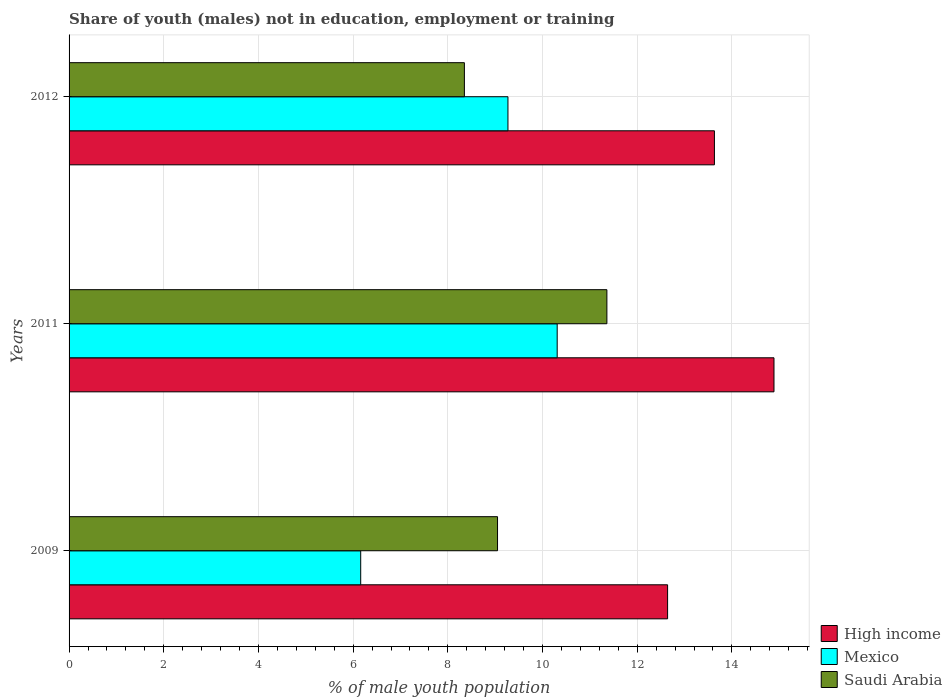How many different coloured bars are there?
Keep it short and to the point. 3. Are the number of bars on each tick of the Y-axis equal?
Provide a succinct answer. Yes. What is the percentage of unemployed males population in in High income in 2012?
Give a very brief answer. 13.63. Across all years, what is the maximum percentage of unemployed males population in in High income?
Offer a terse response. 14.89. Across all years, what is the minimum percentage of unemployed males population in in Mexico?
Your answer should be very brief. 6.16. In which year was the percentage of unemployed males population in in Mexico minimum?
Offer a terse response. 2009. What is the total percentage of unemployed males population in in High income in the graph?
Your answer should be compact. 41.16. What is the difference between the percentage of unemployed males population in in Mexico in 2009 and that in 2012?
Your response must be concise. -3.11. What is the difference between the percentage of unemployed males population in in Saudi Arabia in 2011 and the percentage of unemployed males population in in High income in 2012?
Ensure brevity in your answer.  -2.27. What is the average percentage of unemployed males population in in Saudi Arabia per year?
Give a very brief answer. 9.59. In the year 2012, what is the difference between the percentage of unemployed males population in in Saudi Arabia and percentage of unemployed males population in in Mexico?
Your answer should be very brief. -0.92. In how many years, is the percentage of unemployed males population in in Saudi Arabia greater than 14.4 %?
Keep it short and to the point. 0. What is the ratio of the percentage of unemployed males population in in Mexico in 2009 to that in 2011?
Your answer should be compact. 0.6. Is the difference between the percentage of unemployed males population in in Saudi Arabia in 2009 and 2012 greater than the difference between the percentage of unemployed males population in in Mexico in 2009 and 2012?
Offer a very short reply. Yes. What is the difference between the highest and the second highest percentage of unemployed males population in in Mexico?
Offer a very short reply. 1.04. What is the difference between the highest and the lowest percentage of unemployed males population in in Saudi Arabia?
Make the answer very short. 3.01. Is the sum of the percentage of unemployed males population in in Mexico in 2009 and 2011 greater than the maximum percentage of unemployed males population in in Saudi Arabia across all years?
Make the answer very short. Yes. Is it the case that in every year, the sum of the percentage of unemployed males population in in Saudi Arabia and percentage of unemployed males population in in Mexico is greater than the percentage of unemployed males population in in High income?
Give a very brief answer. Yes. Are the values on the major ticks of X-axis written in scientific E-notation?
Make the answer very short. No. Does the graph contain grids?
Provide a short and direct response. Yes. How many legend labels are there?
Offer a terse response. 3. What is the title of the graph?
Your response must be concise. Share of youth (males) not in education, employment or training. What is the label or title of the X-axis?
Your answer should be very brief. % of male youth population. What is the % of male youth population of High income in 2009?
Your answer should be compact. 12.64. What is the % of male youth population in Mexico in 2009?
Offer a terse response. 6.16. What is the % of male youth population in Saudi Arabia in 2009?
Provide a succinct answer. 9.05. What is the % of male youth population of High income in 2011?
Your answer should be very brief. 14.89. What is the % of male youth population in Mexico in 2011?
Offer a terse response. 10.31. What is the % of male youth population of Saudi Arabia in 2011?
Give a very brief answer. 11.36. What is the % of male youth population of High income in 2012?
Keep it short and to the point. 13.63. What is the % of male youth population of Mexico in 2012?
Your answer should be compact. 9.27. What is the % of male youth population in Saudi Arabia in 2012?
Provide a short and direct response. 8.35. Across all years, what is the maximum % of male youth population of High income?
Give a very brief answer. 14.89. Across all years, what is the maximum % of male youth population of Mexico?
Ensure brevity in your answer.  10.31. Across all years, what is the maximum % of male youth population of Saudi Arabia?
Your answer should be very brief. 11.36. Across all years, what is the minimum % of male youth population of High income?
Keep it short and to the point. 12.64. Across all years, what is the minimum % of male youth population in Mexico?
Give a very brief answer. 6.16. Across all years, what is the minimum % of male youth population of Saudi Arabia?
Offer a terse response. 8.35. What is the total % of male youth population of High income in the graph?
Your answer should be compact. 41.16. What is the total % of male youth population in Mexico in the graph?
Your response must be concise. 25.74. What is the total % of male youth population of Saudi Arabia in the graph?
Your answer should be compact. 28.76. What is the difference between the % of male youth population in High income in 2009 and that in 2011?
Ensure brevity in your answer.  -2.25. What is the difference between the % of male youth population of Mexico in 2009 and that in 2011?
Offer a very short reply. -4.15. What is the difference between the % of male youth population in Saudi Arabia in 2009 and that in 2011?
Your answer should be compact. -2.31. What is the difference between the % of male youth population in High income in 2009 and that in 2012?
Your response must be concise. -0.99. What is the difference between the % of male youth population in Mexico in 2009 and that in 2012?
Your answer should be very brief. -3.11. What is the difference between the % of male youth population of Saudi Arabia in 2009 and that in 2012?
Your answer should be compact. 0.7. What is the difference between the % of male youth population of High income in 2011 and that in 2012?
Provide a succinct answer. 1.26. What is the difference between the % of male youth population in Mexico in 2011 and that in 2012?
Provide a succinct answer. 1.04. What is the difference between the % of male youth population of Saudi Arabia in 2011 and that in 2012?
Provide a succinct answer. 3.01. What is the difference between the % of male youth population of High income in 2009 and the % of male youth population of Mexico in 2011?
Offer a terse response. 2.33. What is the difference between the % of male youth population in High income in 2009 and the % of male youth population in Saudi Arabia in 2011?
Make the answer very short. 1.28. What is the difference between the % of male youth population of Mexico in 2009 and the % of male youth population of Saudi Arabia in 2011?
Provide a short and direct response. -5.2. What is the difference between the % of male youth population in High income in 2009 and the % of male youth population in Mexico in 2012?
Offer a terse response. 3.37. What is the difference between the % of male youth population in High income in 2009 and the % of male youth population in Saudi Arabia in 2012?
Provide a short and direct response. 4.29. What is the difference between the % of male youth population of Mexico in 2009 and the % of male youth population of Saudi Arabia in 2012?
Provide a short and direct response. -2.19. What is the difference between the % of male youth population of High income in 2011 and the % of male youth population of Mexico in 2012?
Your response must be concise. 5.62. What is the difference between the % of male youth population in High income in 2011 and the % of male youth population in Saudi Arabia in 2012?
Your response must be concise. 6.54. What is the difference between the % of male youth population of Mexico in 2011 and the % of male youth population of Saudi Arabia in 2012?
Keep it short and to the point. 1.96. What is the average % of male youth population in High income per year?
Your response must be concise. 13.72. What is the average % of male youth population in Mexico per year?
Offer a terse response. 8.58. What is the average % of male youth population of Saudi Arabia per year?
Offer a very short reply. 9.59. In the year 2009, what is the difference between the % of male youth population in High income and % of male youth population in Mexico?
Make the answer very short. 6.48. In the year 2009, what is the difference between the % of male youth population in High income and % of male youth population in Saudi Arabia?
Your answer should be compact. 3.59. In the year 2009, what is the difference between the % of male youth population of Mexico and % of male youth population of Saudi Arabia?
Your response must be concise. -2.89. In the year 2011, what is the difference between the % of male youth population in High income and % of male youth population in Mexico?
Your response must be concise. 4.58. In the year 2011, what is the difference between the % of male youth population of High income and % of male youth population of Saudi Arabia?
Your response must be concise. 3.53. In the year 2011, what is the difference between the % of male youth population in Mexico and % of male youth population in Saudi Arabia?
Your answer should be compact. -1.05. In the year 2012, what is the difference between the % of male youth population in High income and % of male youth population in Mexico?
Ensure brevity in your answer.  4.36. In the year 2012, what is the difference between the % of male youth population of High income and % of male youth population of Saudi Arabia?
Offer a terse response. 5.28. In the year 2012, what is the difference between the % of male youth population of Mexico and % of male youth population of Saudi Arabia?
Provide a short and direct response. 0.92. What is the ratio of the % of male youth population of High income in 2009 to that in 2011?
Offer a very short reply. 0.85. What is the ratio of the % of male youth population in Mexico in 2009 to that in 2011?
Your response must be concise. 0.6. What is the ratio of the % of male youth population of Saudi Arabia in 2009 to that in 2011?
Offer a very short reply. 0.8. What is the ratio of the % of male youth population of High income in 2009 to that in 2012?
Your answer should be very brief. 0.93. What is the ratio of the % of male youth population in Mexico in 2009 to that in 2012?
Keep it short and to the point. 0.66. What is the ratio of the % of male youth population of Saudi Arabia in 2009 to that in 2012?
Give a very brief answer. 1.08. What is the ratio of the % of male youth population in High income in 2011 to that in 2012?
Make the answer very short. 1.09. What is the ratio of the % of male youth population in Mexico in 2011 to that in 2012?
Your answer should be very brief. 1.11. What is the ratio of the % of male youth population of Saudi Arabia in 2011 to that in 2012?
Offer a terse response. 1.36. What is the difference between the highest and the second highest % of male youth population of High income?
Provide a short and direct response. 1.26. What is the difference between the highest and the second highest % of male youth population in Mexico?
Offer a terse response. 1.04. What is the difference between the highest and the second highest % of male youth population in Saudi Arabia?
Offer a very short reply. 2.31. What is the difference between the highest and the lowest % of male youth population in High income?
Your answer should be compact. 2.25. What is the difference between the highest and the lowest % of male youth population in Mexico?
Ensure brevity in your answer.  4.15. What is the difference between the highest and the lowest % of male youth population of Saudi Arabia?
Ensure brevity in your answer.  3.01. 